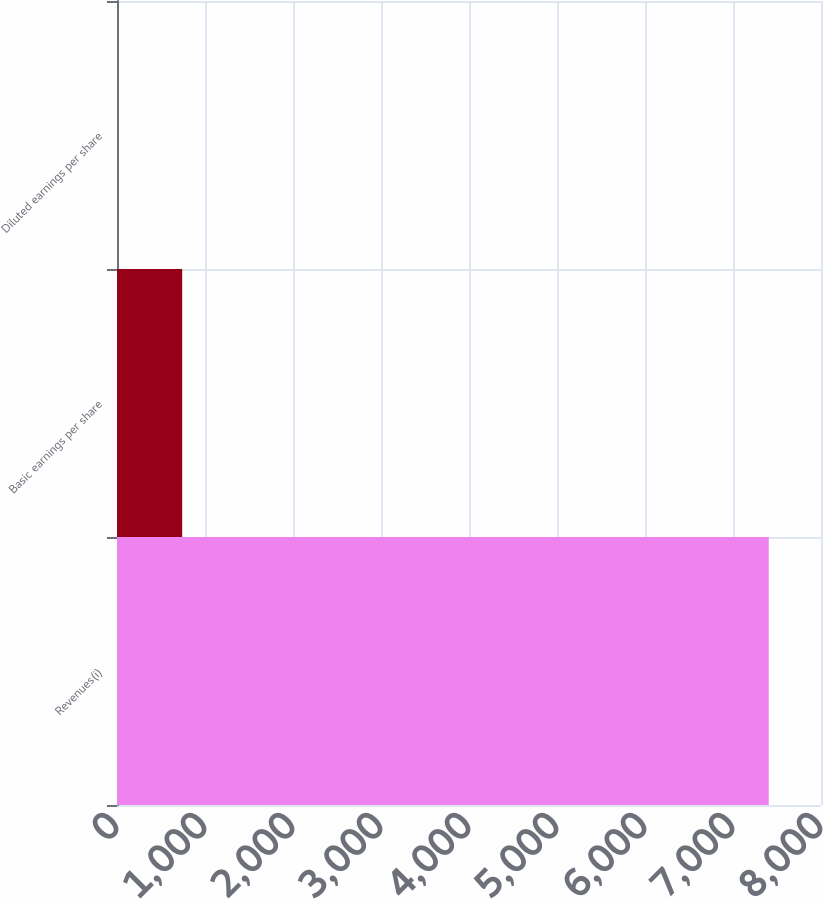Convert chart. <chart><loc_0><loc_0><loc_500><loc_500><bar_chart><fcel>Revenues(i)<fcel>Basic earnings per share<fcel>Diluted earnings per share<nl><fcel>7406<fcel>741.07<fcel>0.52<nl></chart> 